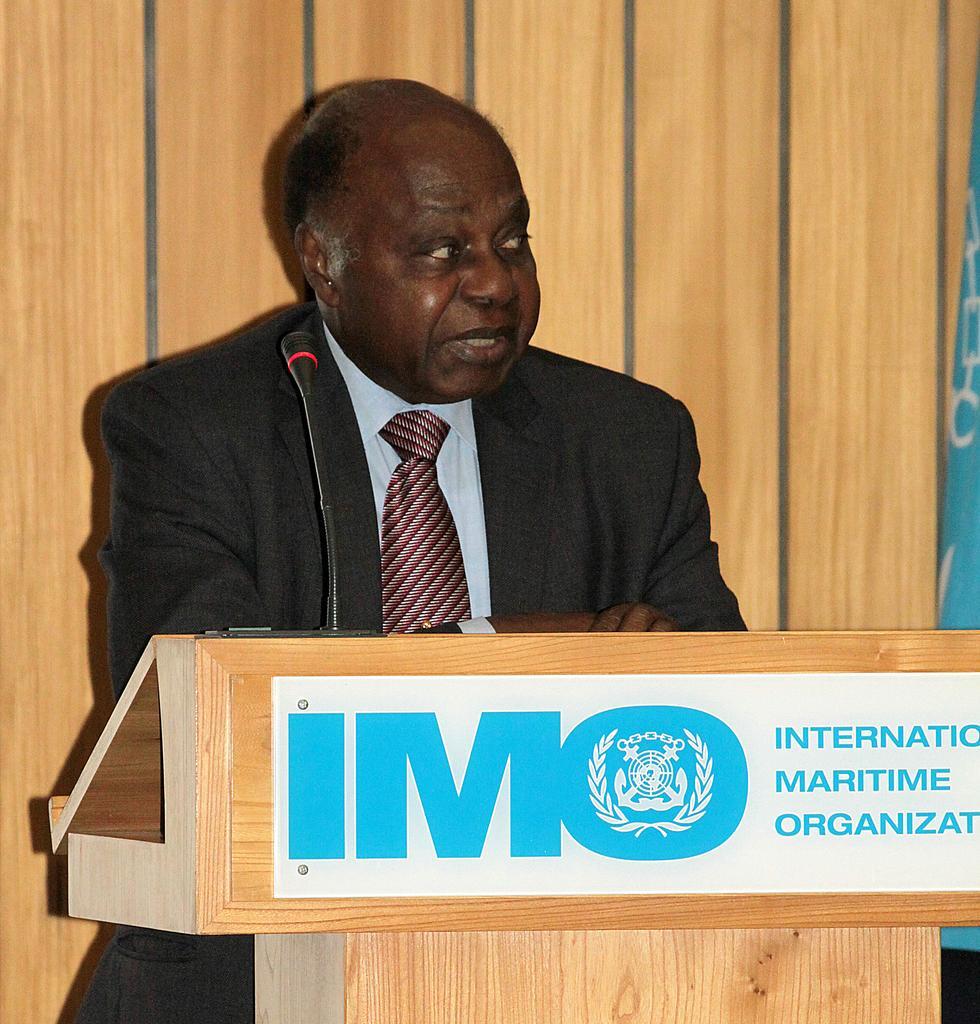Could you give a brief overview of what you see in this image? In this image I can see a man is speaking near the podium, he is wearing the tie, shirt, coat. At the bottom there is the board in white color. 